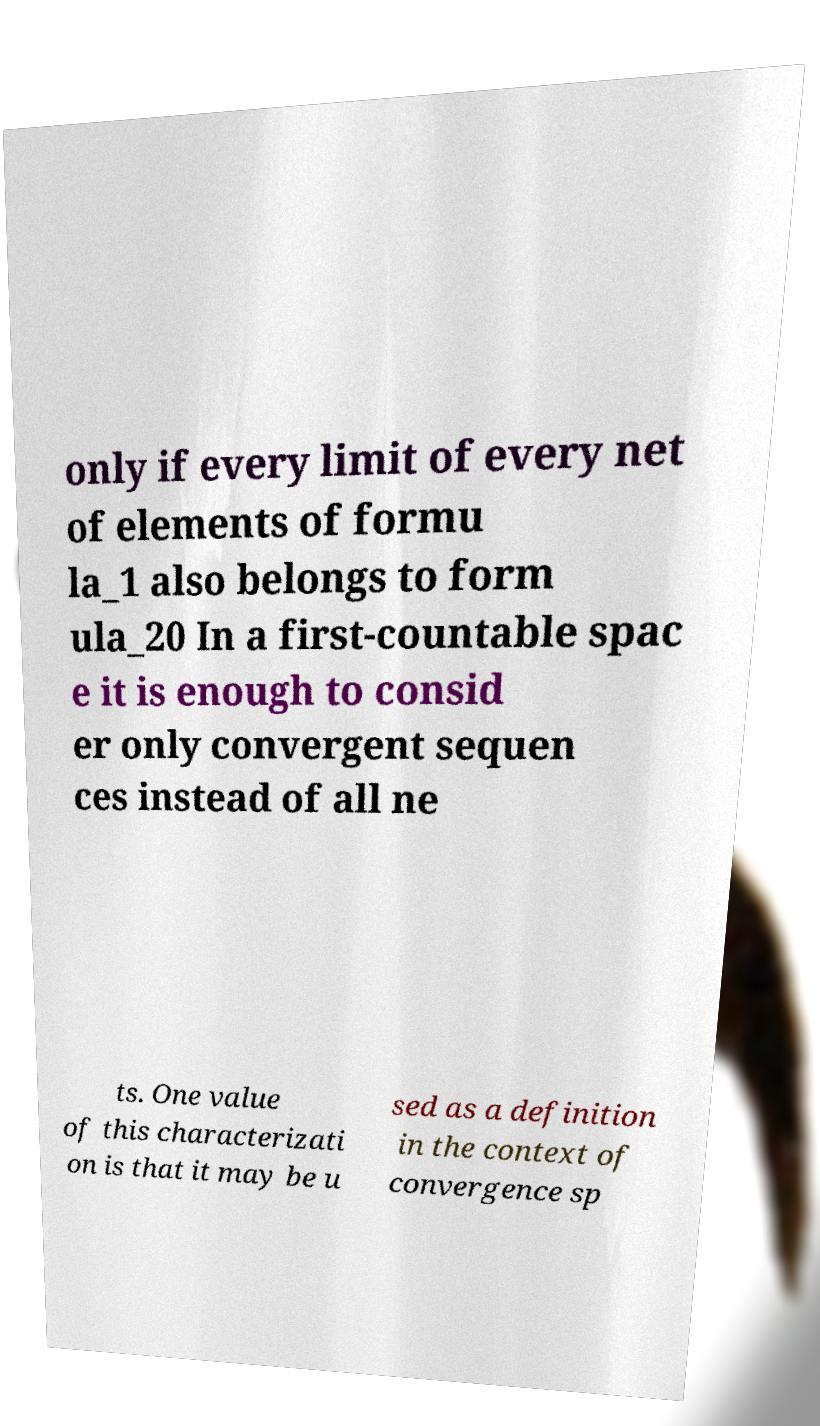Can you accurately transcribe the text from the provided image for me? only if every limit of every net of elements of formu la_1 also belongs to form ula_20 In a first-countable spac e it is enough to consid er only convergent sequen ces instead of all ne ts. One value of this characterizati on is that it may be u sed as a definition in the context of convergence sp 